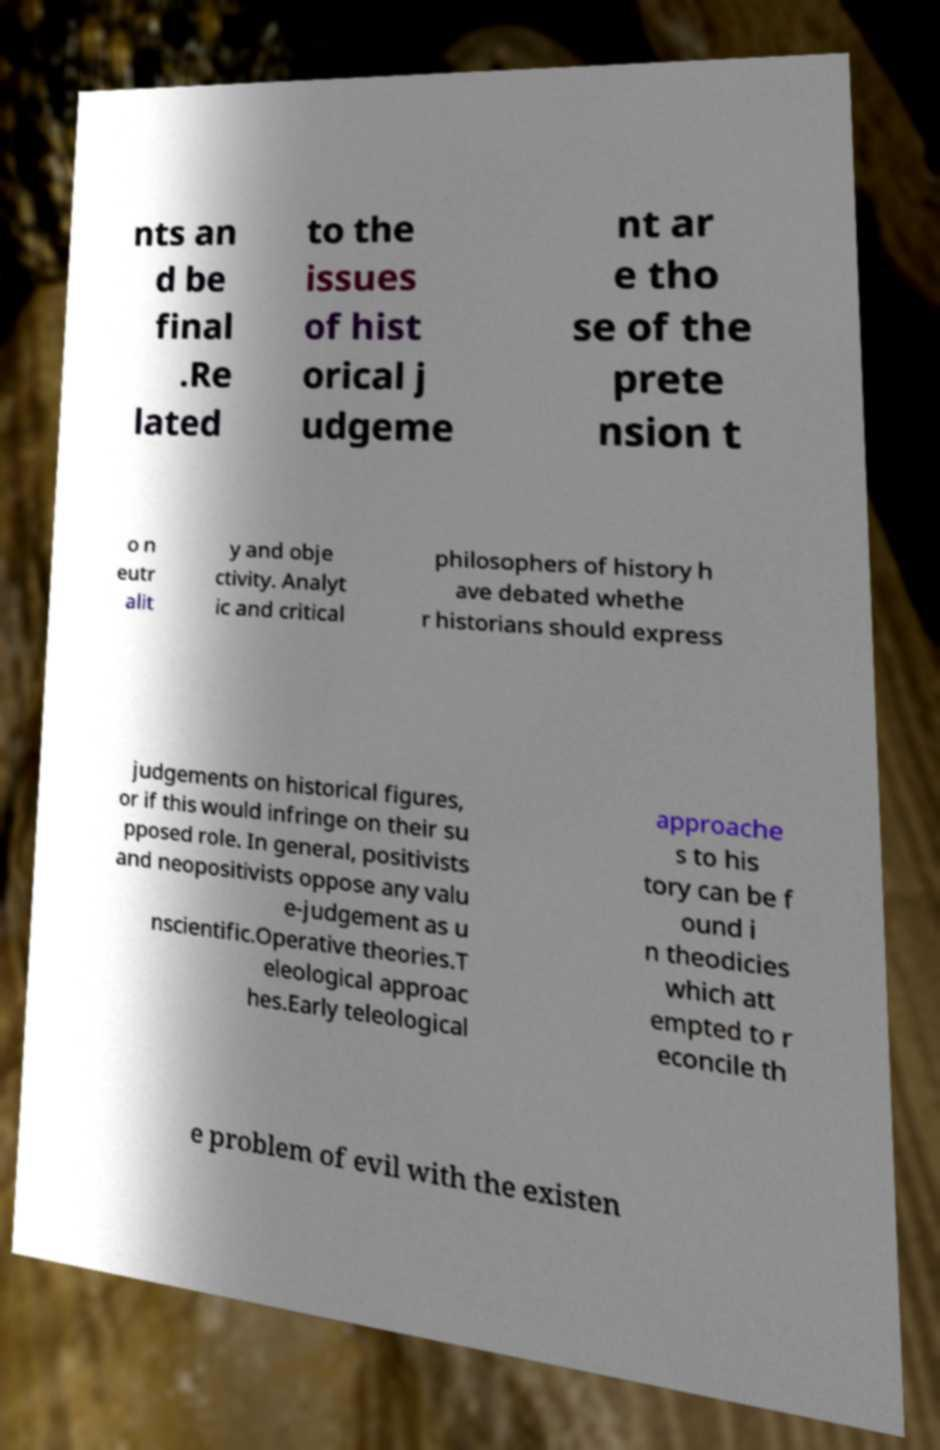Can you read and provide the text displayed in the image?This photo seems to have some interesting text. Can you extract and type it out for me? nts an d be final .Re lated to the issues of hist orical j udgeme nt ar e tho se of the prete nsion t o n eutr alit y and obje ctivity. Analyt ic and critical philosophers of history h ave debated whethe r historians should express judgements on historical figures, or if this would infringe on their su pposed role. In general, positivists and neopositivists oppose any valu e-judgement as u nscientific.Operative theories.T eleological approac hes.Early teleological approache s to his tory can be f ound i n theodicies which att empted to r econcile th e problem of evil with the existen 